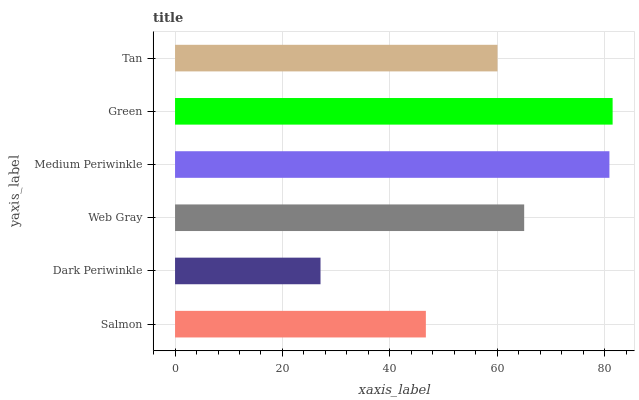Is Dark Periwinkle the minimum?
Answer yes or no. Yes. Is Green the maximum?
Answer yes or no. Yes. Is Web Gray the minimum?
Answer yes or no. No. Is Web Gray the maximum?
Answer yes or no. No. Is Web Gray greater than Dark Periwinkle?
Answer yes or no. Yes. Is Dark Periwinkle less than Web Gray?
Answer yes or no. Yes. Is Dark Periwinkle greater than Web Gray?
Answer yes or no. No. Is Web Gray less than Dark Periwinkle?
Answer yes or no. No. Is Web Gray the high median?
Answer yes or no. Yes. Is Tan the low median?
Answer yes or no. Yes. Is Medium Periwinkle the high median?
Answer yes or no. No. Is Medium Periwinkle the low median?
Answer yes or no. No. 